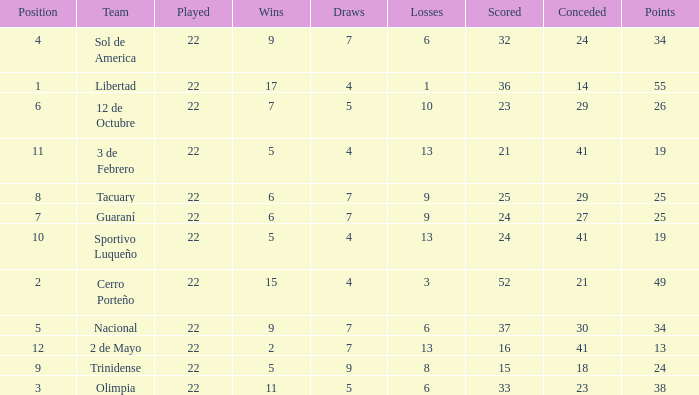What is the fewest wins that has fewer than 23 goals scored, team of 2 de Mayo, and fewer than 7 draws? None. 